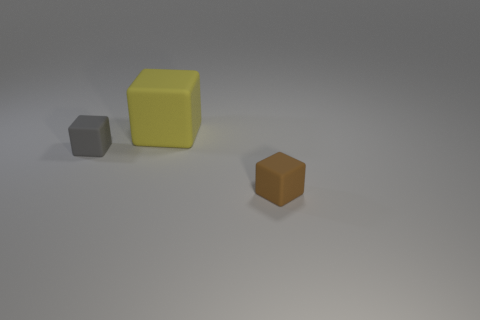Subtract all gray matte blocks. How many blocks are left? 2 Subtract 3 blocks. How many blocks are left? 0 Subtract all gray cubes. Subtract all yellow cylinders. How many cubes are left? 2 Subtract all green spheres. How many brown blocks are left? 1 Subtract all gray metallic spheres. Subtract all small gray matte blocks. How many objects are left? 2 Add 2 gray cubes. How many gray cubes are left? 3 Add 1 tiny brown rubber cubes. How many tiny brown rubber cubes exist? 2 Add 1 big purple rubber balls. How many objects exist? 4 Subtract all yellow blocks. How many blocks are left? 2 Subtract 1 gray blocks. How many objects are left? 2 